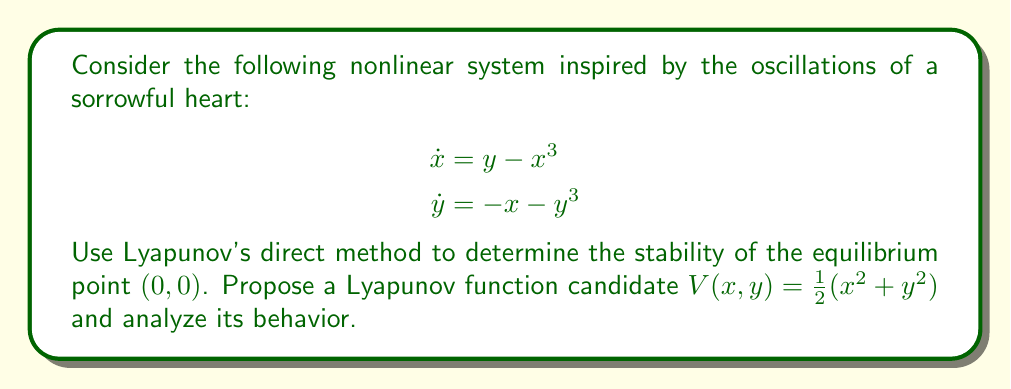Provide a solution to this math problem. 1. First, we identify the equilibrium point $(0,0)$ of the system.

2. We propose the Lyapunov function candidate: $V(x,y) = \frac{1}{2}(x^2 + y^2)$

3. Check if $V(x,y)$ is positive definite:
   $V(0,0) = 0$ and $V(x,y) > 0$ for all $(x,y) \neq (0,0)$, so it is positive definite.

4. Calculate the time derivative of $V(x,y)$ along the system trajectories:

   $$\begin{aligned}
   \dot{V}(x,y) &= \frac{\partial V}{\partial x}\dot{x} + \frac{\partial V}{\partial y}\dot{y} \\
   &= x\dot{x} + y\dot{y} \\
   &= x(y - x^3) + y(-x - y^3) \\
   &= xy - x^4 - xy - y^4 \\
   &= -(x^4 + y^4)
   \end{aligned}$$

5. Analyze $\dot{V}(x,y)$:
   $\dot{V}(x,y) \leq 0$ for all $(x,y)$, and $\dot{V}(x,y) = 0$ only when $(x,y) = (0,0)$

6. Since $V(x,y)$ is positive definite and $\dot{V}(x,y)$ is negative semi-definite, we can conclude that the equilibrium point $(0,0)$ is stable.

7. To prove asymptotic stability, we need to use LaSalle's Invariance Principle:
   The largest invariant set where $\dot{V}(x,y) = 0$ is only the point $(0,0)$.

8. Therefore, all trajectories converge to $(0,0)$ as $t \to \infty$.
Answer: The equilibrium point $(0,0)$ is asymptotically stable. 